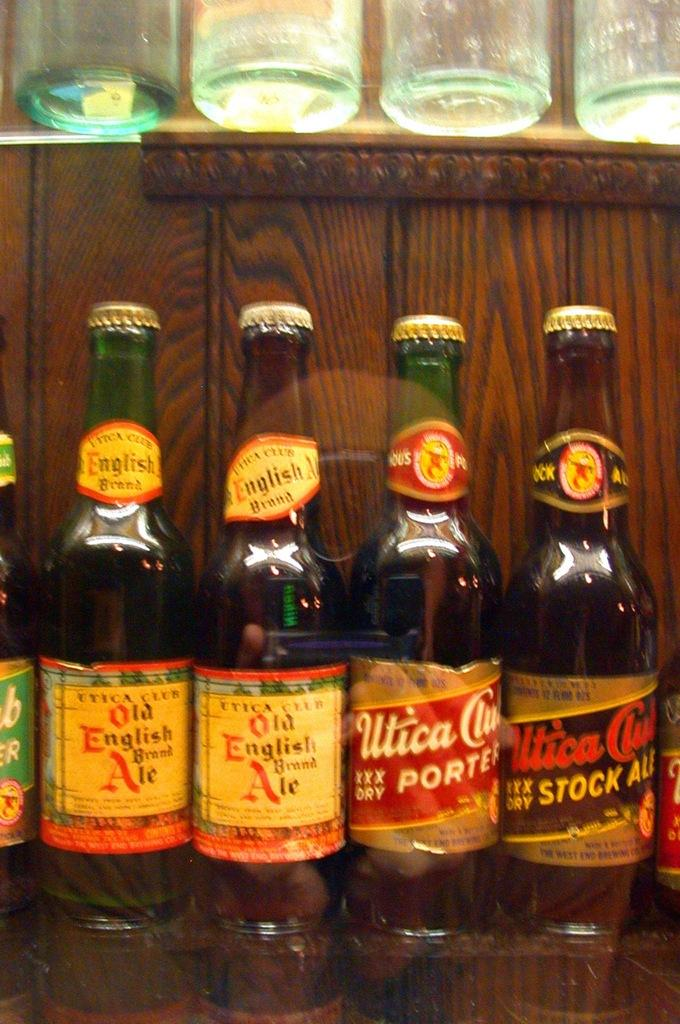<image>
Create a compact narrative representing the image presented. several beer bottles lined up including Old English Ale and Utica Club 